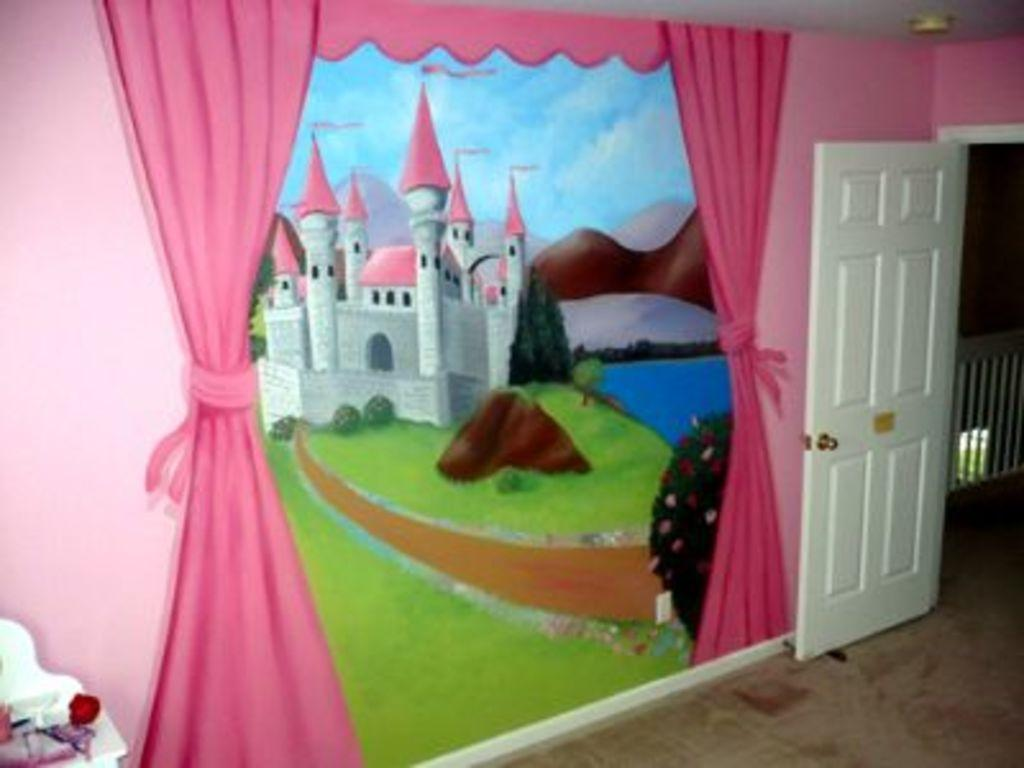What is the main subject of the picture? The main subject of the picture is a fort. What natural features can be seen in the picture? There is a pond and a mountain in the picture. What objects are located at the right side of the picture? There is a curtain and a door at the right side of the picture. What sense is being stimulated by the fort in the image? The image is visual, so it primarily stimulates the sense of sight. However, the fort itself does not stimulate any specific sense beyond that. 